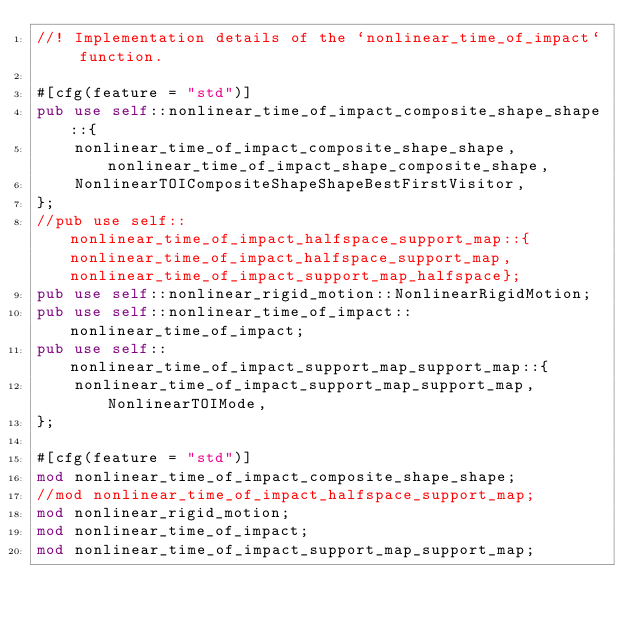Convert code to text. <code><loc_0><loc_0><loc_500><loc_500><_Rust_>//! Implementation details of the `nonlinear_time_of_impact` function.

#[cfg(feature = "std")]
pub use self::nonlinear_time_of_impact_composite_shape_shape::{
    nonlinear_time_of_impact_composite_shape_shape, nonlinear_time_of_impact_shape_composite_shape,
    NonlinearTOICompositeShapeShapeBestFirstVisitor,
};
//pub use self::nonlinear_time_of_impact_halfspace_support_map::{nonlinear_time_of_impact_halfspace_support_map, nonlinear_time_of_impact_support_map_halfspace};
pub use self::nonlinear_rigid_motion::NonlinearRigidMotion;
pub use self::nonlinear_time_of_impact::nonlinear_time_of_impact;
pub use self::nonlinear_time_of_impact_support_map_support_map::{
    nonlinear_time_of_impact_support_map_support_map, NonlinearTOIMode,
};

#[cfg(feature = "std")]
mod nonlinear_time_of_impact_composite_shape_shape;
//mod nonlinear_time_of_impact_halfspace_support_map;
mod nonlinear_rigid_motion;
mod nonlinear_time_of_impact;
mod nonlinear_time_of_impact_support_map_support_map;
</code> 